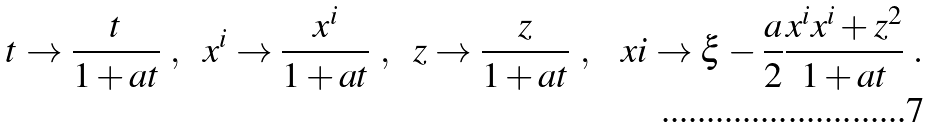Convert formula to latex. <formula><loc_0><loc_0><loc_500><loc_500>t \to \frac { t } { 1 + a t } \ , \ \ x ^ { i } \to \frac { x ^ { i } } { 1 + a t } \ , \ \ z \to \frac { z } { 1 + a t } \ , \ \ \ x i \to \xi - \frac { a } { 2 } \frac { x ^ { i } x ^ { i } + z ^ { 2 } } { 1 + a t } \ .</formula> 